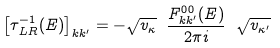Convert formula to latex. <formula><loc_0><loc_0><loc_500><loc_500>\left [ \tau ^ { - 1 } _ { \, L R } ( E ) \right ] _ { k k ^ { \prime } } = - \sqrt { v _ { \kappa } } \ \frac { F ^ { 0 0 } _ { k k ^ { \prime } } ( E ) } { 2 \pi i } \ \sqrt { v _ { \kappa ^ { \prime } } }</formula> 